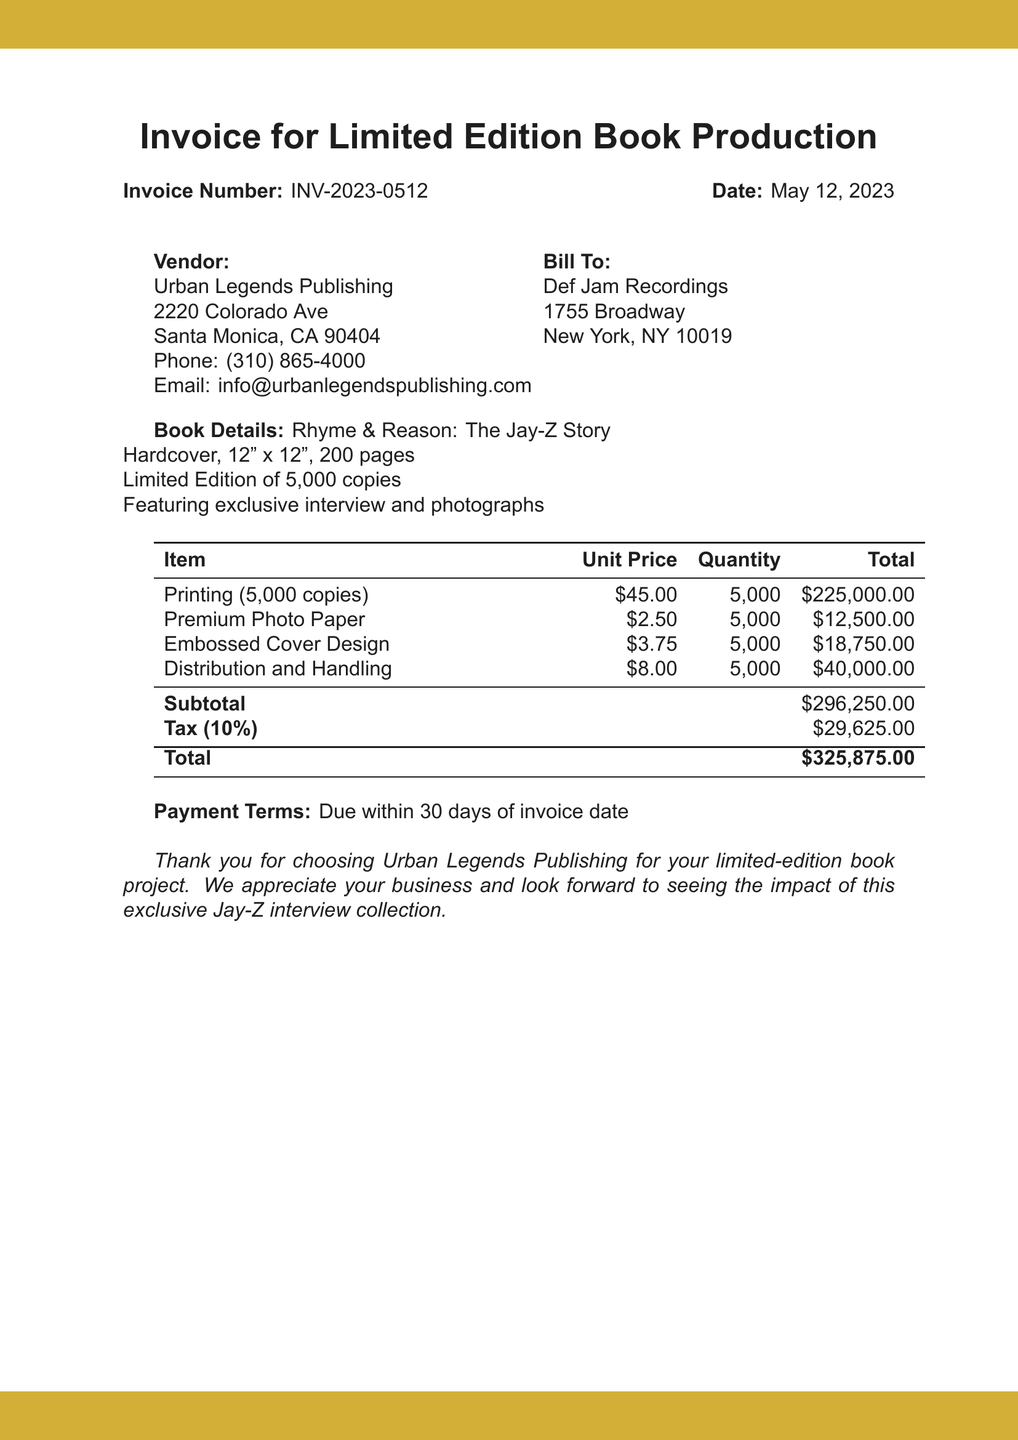What is the invoice number? The invoice number is stated in the document as INV-2023-0512.
Answer: INV-2023-0512 What is the date of the invoice? The date of the invoice is provided as May 12, 2023.
Answer: May 12, 2023 Who is the vendor? The document specifies the vendor as Urban Legends Publishing.
Answer: Urban Legends Publishing What is the total amount due? The total amount due is calculated and listed as $325,875.00 in the document.
Answer: $325,875.00 How many copies of the book are being printed? The document indicates that 5,000 copies of the book are being printed.
Answer: 5,000 What is the tax rate applied? The tax rate mentioned in the document is 10%.
Answer: 10% What type of binding is used for the book? The book is specified to be hardcover in the document.
Answer: Hardcover What is the payment term stated in the invoice? The payment term mentioned is due within 30 days of the invoice date.
Answer: 30 days 